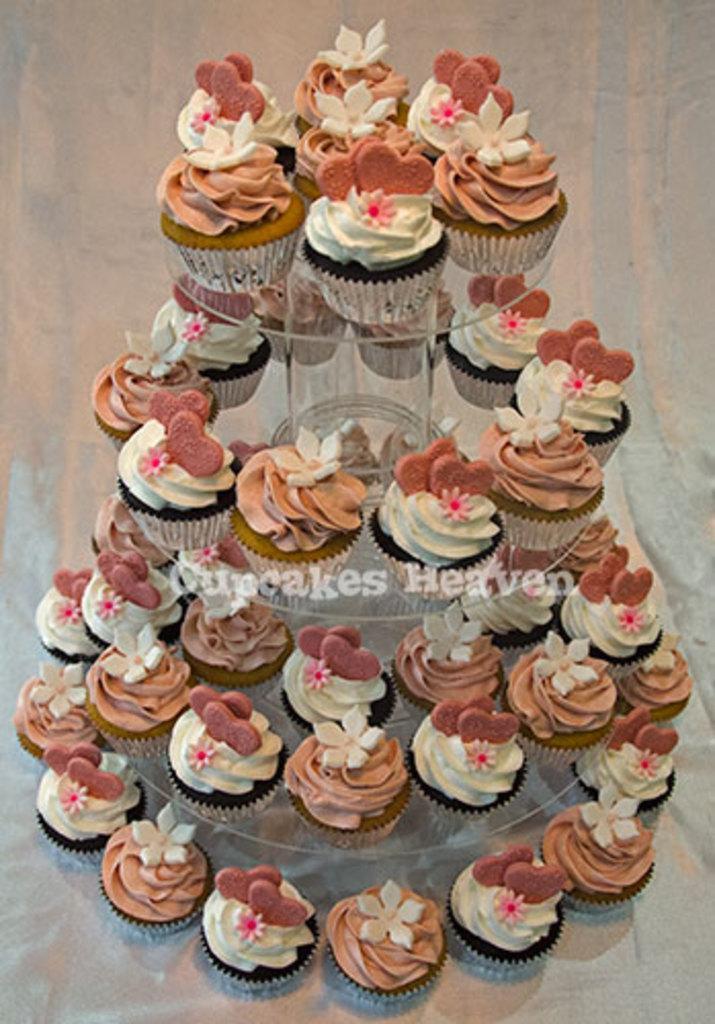How would you summarize this image in a sentence or two? In this image I can see few colorful cupcakes on the cake stand. Background is cream and white color. 